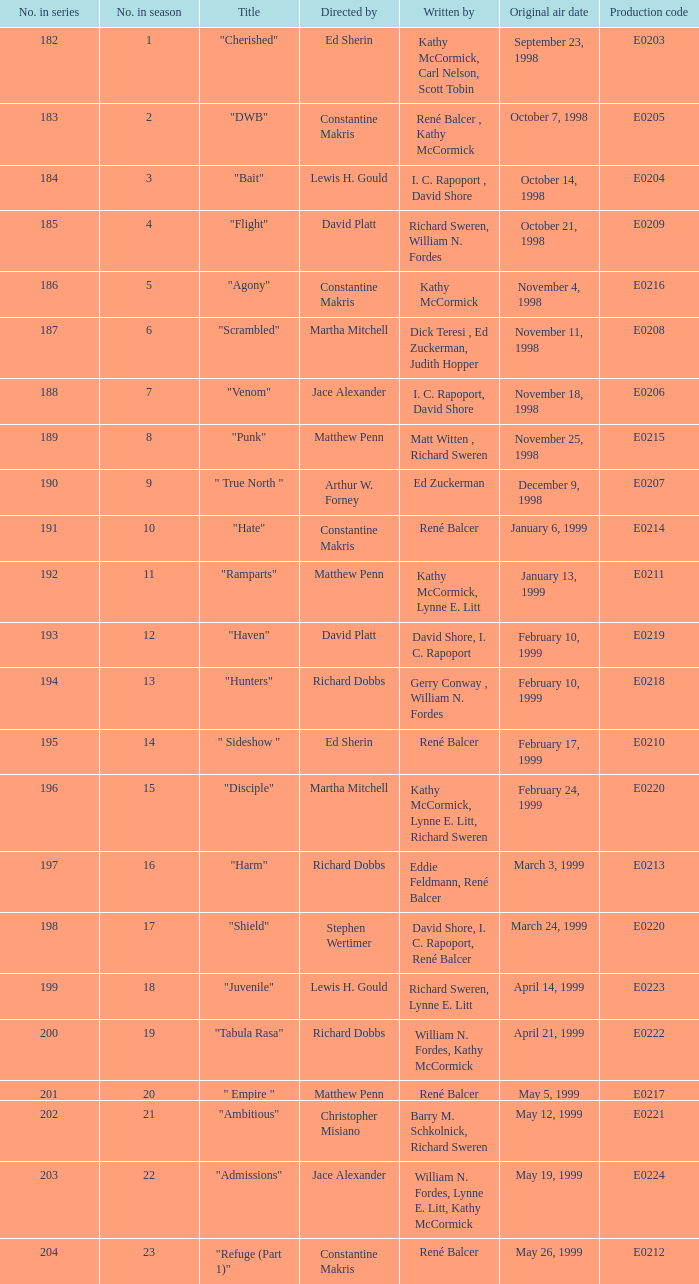What is the title of the episode with the original air date October 21, 1998? "Flight". 